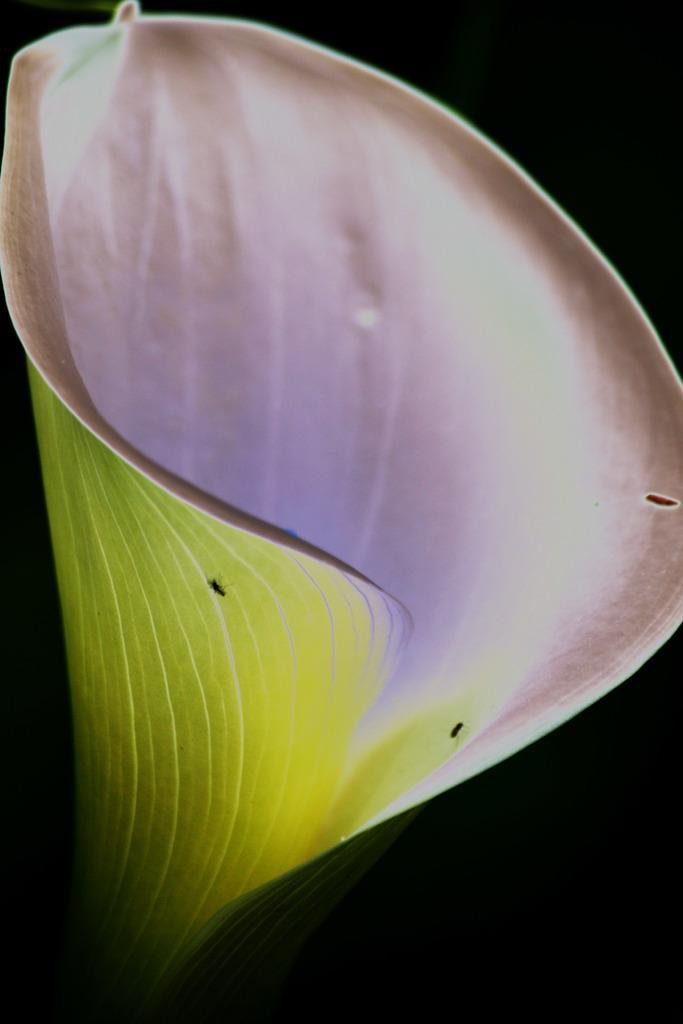Describe this image in one or two sentences. In this image there is a flower having few insects on it. Background is in black color. 